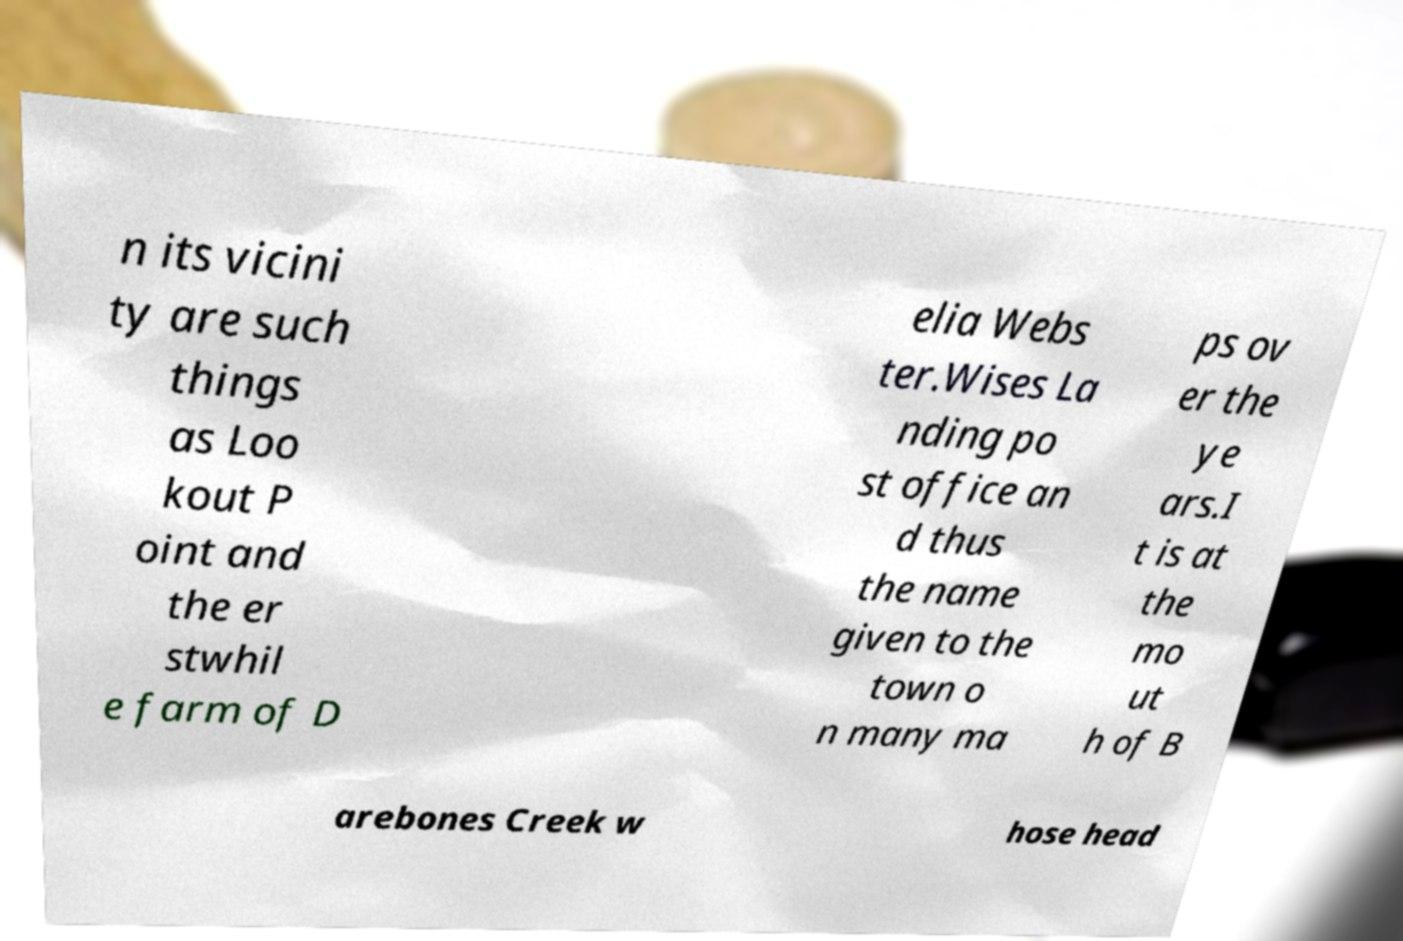Could you extract and type out the text from this image? n its vicini ty are such things as Loo kout P oint and the er stwhil e farm of D elia Webs ter.Wises La nding po st office an d thus the name given to the town o n many ma ps ov er the ye ars.I t is at the mo ut h of B arebones Creek w hose head 